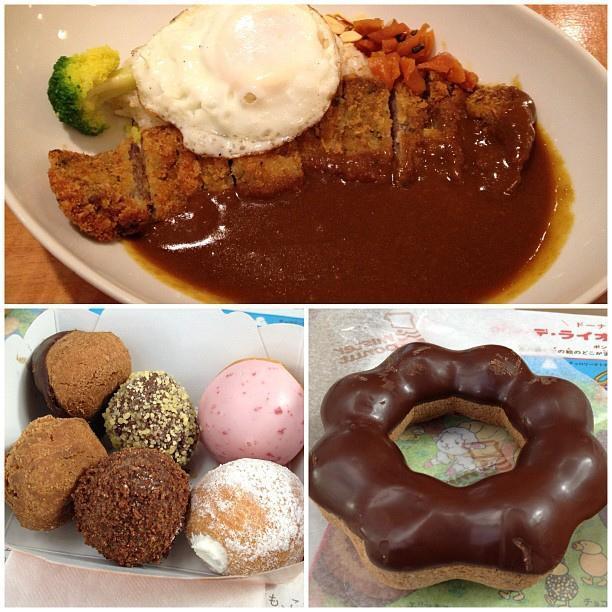How many donuts are in the photo?
Give a very brief answer. 7. How many bowls can you see?
Give a very brief answer. 2. How many people are wearing a red hat?
Give a very brief answer. 0. 